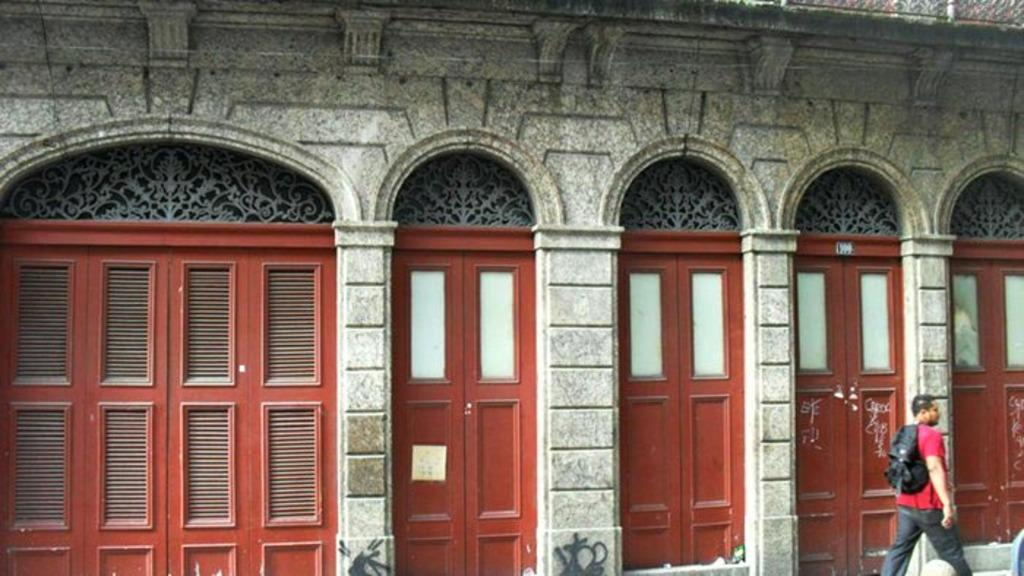What type of structure is present in the image? There is a building in the image. What architectural features can be seen on the building? The building has arches. What other elements are present on the building? The building has doors. Who is present in the image besides the building? There is a man in the image. What is the man wearing? The man is wearing a bag. What is the man doing in the image? The man is walking on the right side. What type of cherry is the man holding in his hands in the image? There is no cherry present in the image, and the man is not holding anything in his hands. How many marks can be seen on the building in the image? There is no mention of any marks on the building in the image. 